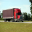The given image can contain some animals; they can be animals typically found in the wild or domesticated animals. The picture could also contain something that does not fit this description. Your job is to identify if the subject of the image is an animal or not. The subject of the image is a semi-truck, which is a non-living object and does not fall under the category of animals, whether wild or domesticated. Based on the provided picture, there are no animals visible, nor are there elements that typically indicate the presence of animals such as habitats or feeding grounds. The image strictly features an inanimate object, specifically a vehicle designed for transportation of goods, and does not contain any biological entities. 